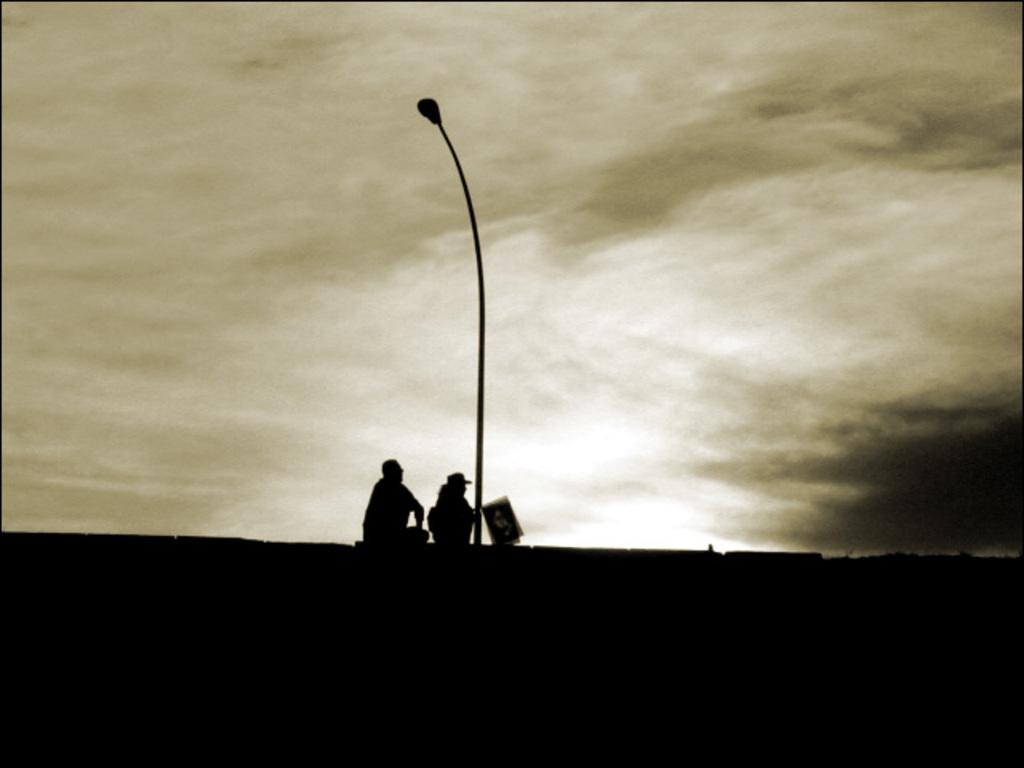How many people are in the image? There are two persons in the image. What are the persons doing in the image? The persons are sitting at a current pole. What can be seen in the background of the image? There is a sky visible in the background of the image. What is the condition of the sky in the image? Clouds are present in the sky. What type of sack can be seen being carried by one of the persons in the image? There is no sack present in the image; the persons are sitting at a current pole. What do the persons believe in, as depicted in the image? The image does not provide any information about the beliefs of the persons. 